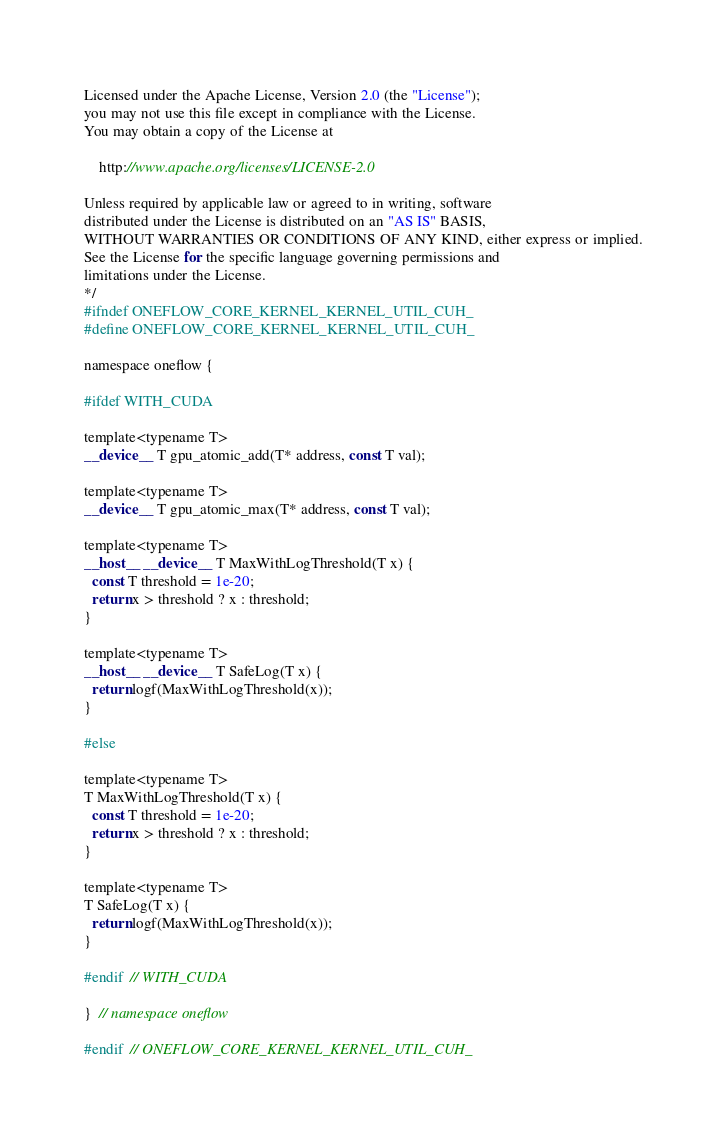Convert code to text. <code><loc_0><loc_0><loc_500><loc_500><_Cuda_>Licensed under the Apache License, Version 2.0 (the "License");
you may not use this file except in compliance with the License.
You may obtain a copy of the License at

    http://www.apache.org/licenses/LICENSE-2.0

Unless required by applicable law or agreed to in writing, software
distributed under the License is distributed on an "AS IS" BASIS,
WITHOUT WARRANTIES OR CONDITIONS OF ANY KIND, either express or implied.
See the License for the specific language governing permissions and
limitations under the License.
*/
#ifndef ONEFLOW_CORE_KERNEL_KERNEL_UTIL_CUH_
#define ONEFLOW_CORE_KERNEL_KERNEL_UTIL_CUH_

namespace oneflow {

#ifdef WITH_CUDA

template<typename T>
__device__ T gpu_atomic_add(T* address, const T val);

template<typename T>
__device__ T gpu_atomic_max(T* address, const T val);

template<typename T>
__host__ __device__ T MaxWithLogThreshold(T x) {
  const T threshold = 1e-20;
  return x > threshold ? x : threshold;
}

template<typename T>
__host__ __device__ T SafeLog(T x) {
  return logf(MaxWithLogThreshold(x));
}

#else

template<typename T>
T MaxWithLogThreshold(T x) {
  const T threshold = 1e-20;
  return x > threshold ? x : threshold;
}

template<typename T>
T SafeLog(T x) {
  return logf(MaxWithLogThreshold(x));
}

#endif  // WITH_CUDA

}  // namespace oneflow

#endif  // ONEFLOW_CORE_KERNEL_KERNEL_UTIL_CUH_
</code> 